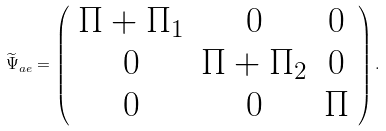<formula> <loc_0><loc_0><loc_500><loc_500>\widetilde { \Psi } _ { a e } = \left ( \begin{array} { c c c } \Pi + \Pi _ { 1 } & 0 & 0 \\ 0 & \Pi + \Pi _ { 2 } & 0 \\ 0 & 0 & \Pi \\ \end{array} \right ) .</formula> 